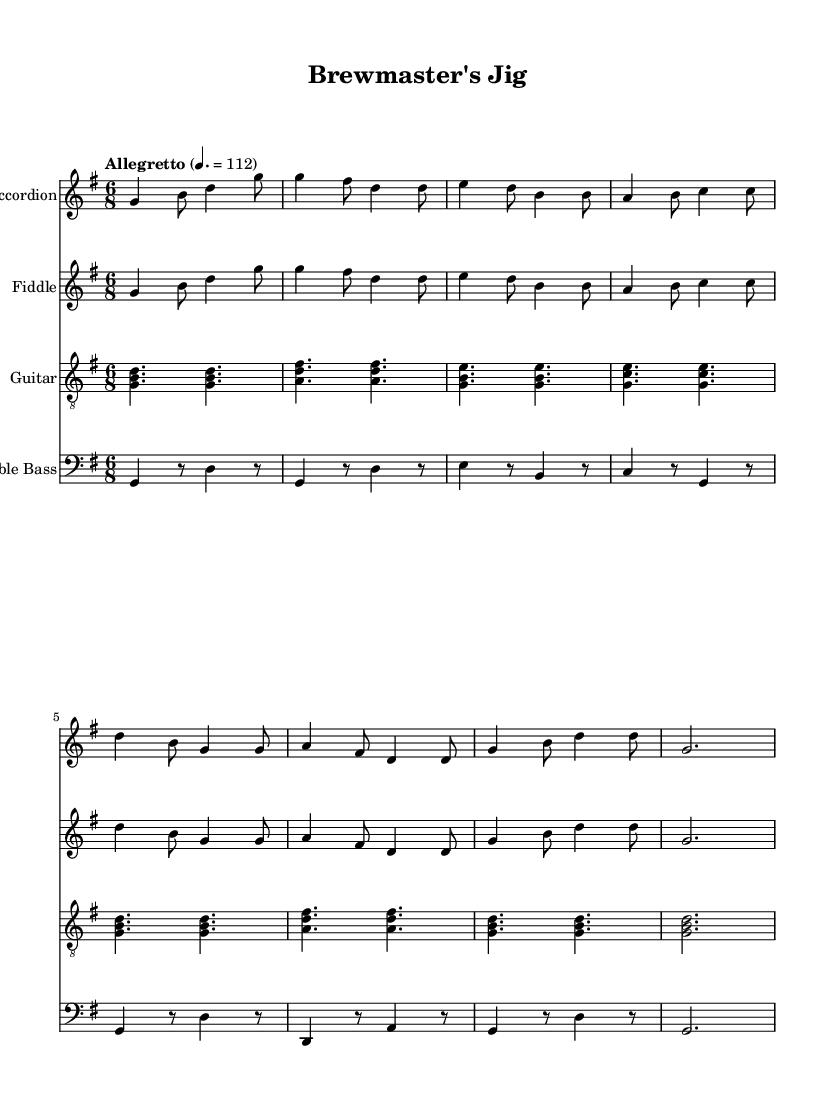What is the key signature of this music? The key signature is G major, which has one sharp (F#).
Answer: G major What is the time signature of this music? The time signature is 6/8, which indicates six eighth notes in each measure.
Answer: 6/8 What is the tempo marking for this piece? The tempo marking is "Allegretto" at a speed of 112 beats per minute.
Answer: Allegretto How many instruments are featured in this score? There are four instruments: accordion, fiddle, guitar, and double bass, each notated on its own staff.
Answer: Four What is the rhythmic pattern of the first measure in terms of note durations? The first measure contains a quarter note, two eighth notes, a quarter note, and another eighth note, creating a distinct rhythm.
Answer: Quarter, two eighths, quarter, eighth Which instrument plays the melody throughout the piece? The accordion and fiddle are playing the same melody in unison, both notated on the treble clef staff.
Answer: Accordion and fiddle What is the significant characteristic of the overall style of this piece? The piece has a rustic folk characteristic, evoking an atmosphere reminiscent of traditional beer halls, suitable for social gatherings.
Answer: Rustic folk 